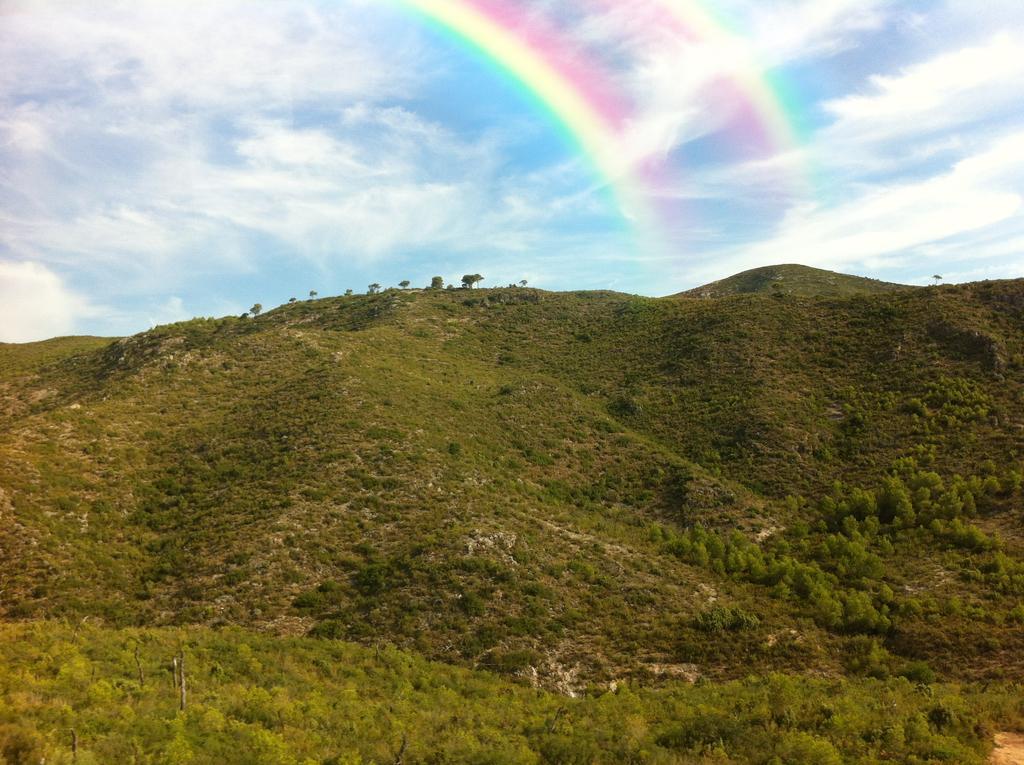Could you give a brief overview of what you see in this image? In this image we can see the mountain with some trees and plants and at the top we can see the sky with double rainbow. 